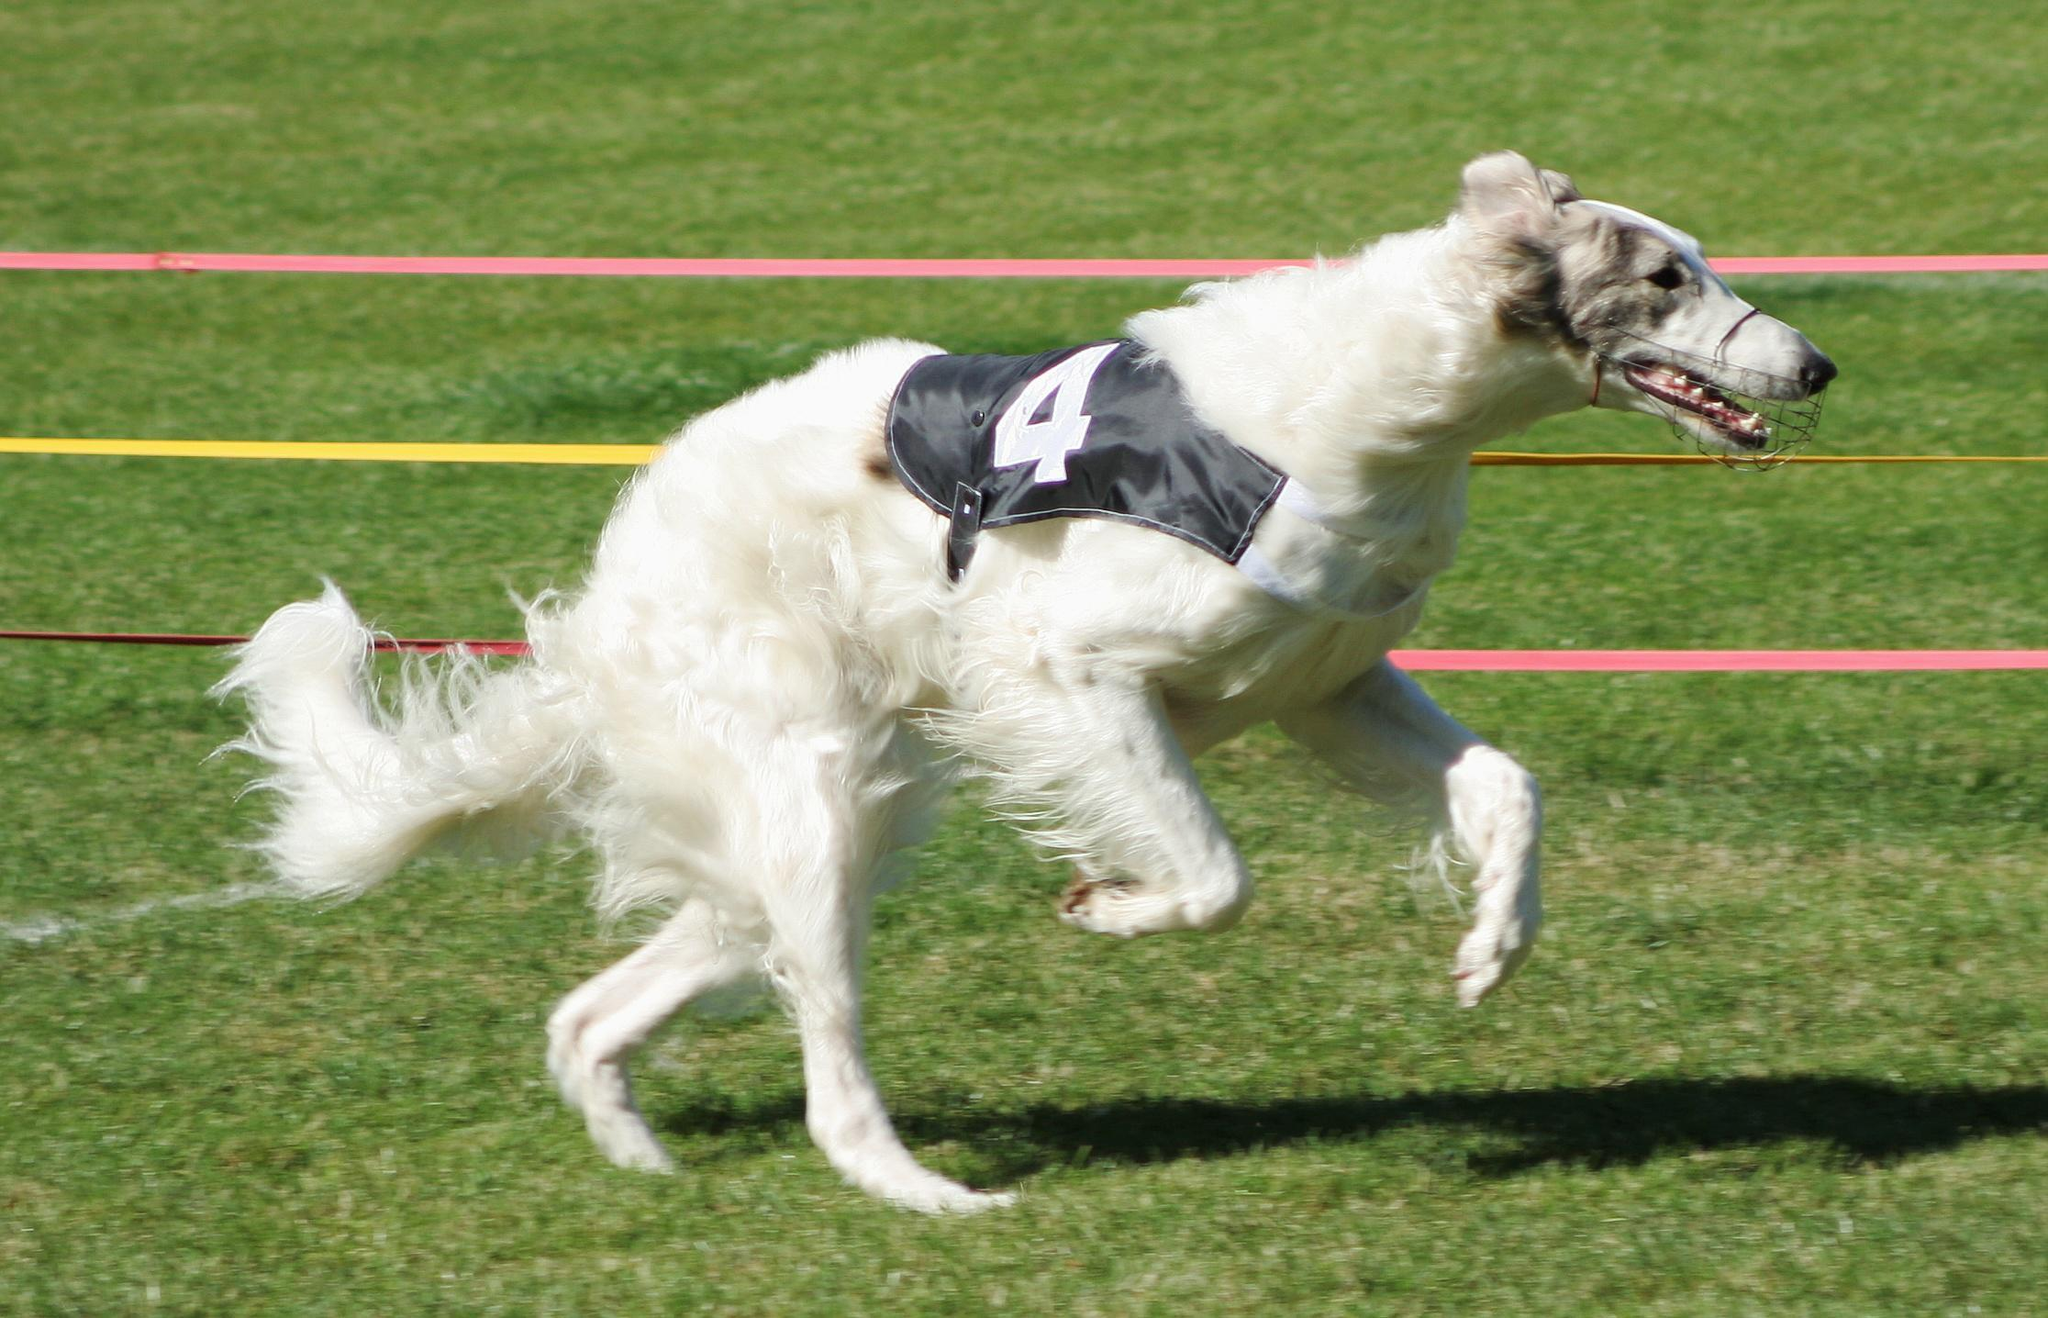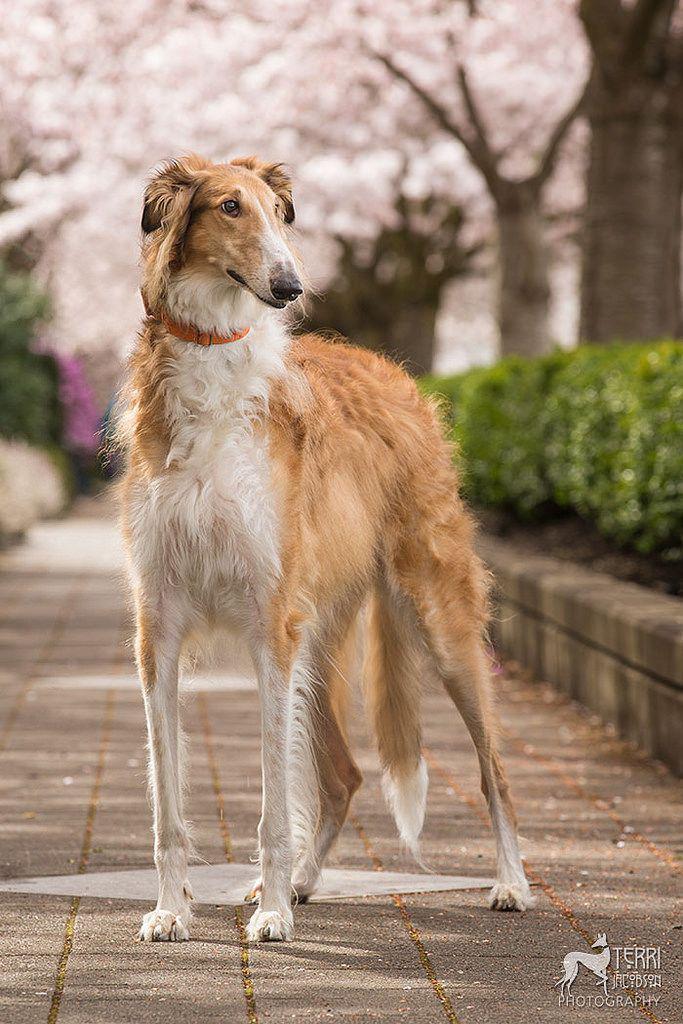The first image is the image on the left, the second image is the image on the right. Considering the images on both sides, is "There is one dog in one of the images, and four or more dogs in the other image." valid? Answer yes or no. No. The first image is the image on the left, the second image is the image on the right. Analyze the images presented: Is the assertion "A person is standing with the dog in the image on the right." valid? Answer yes or no. No. 